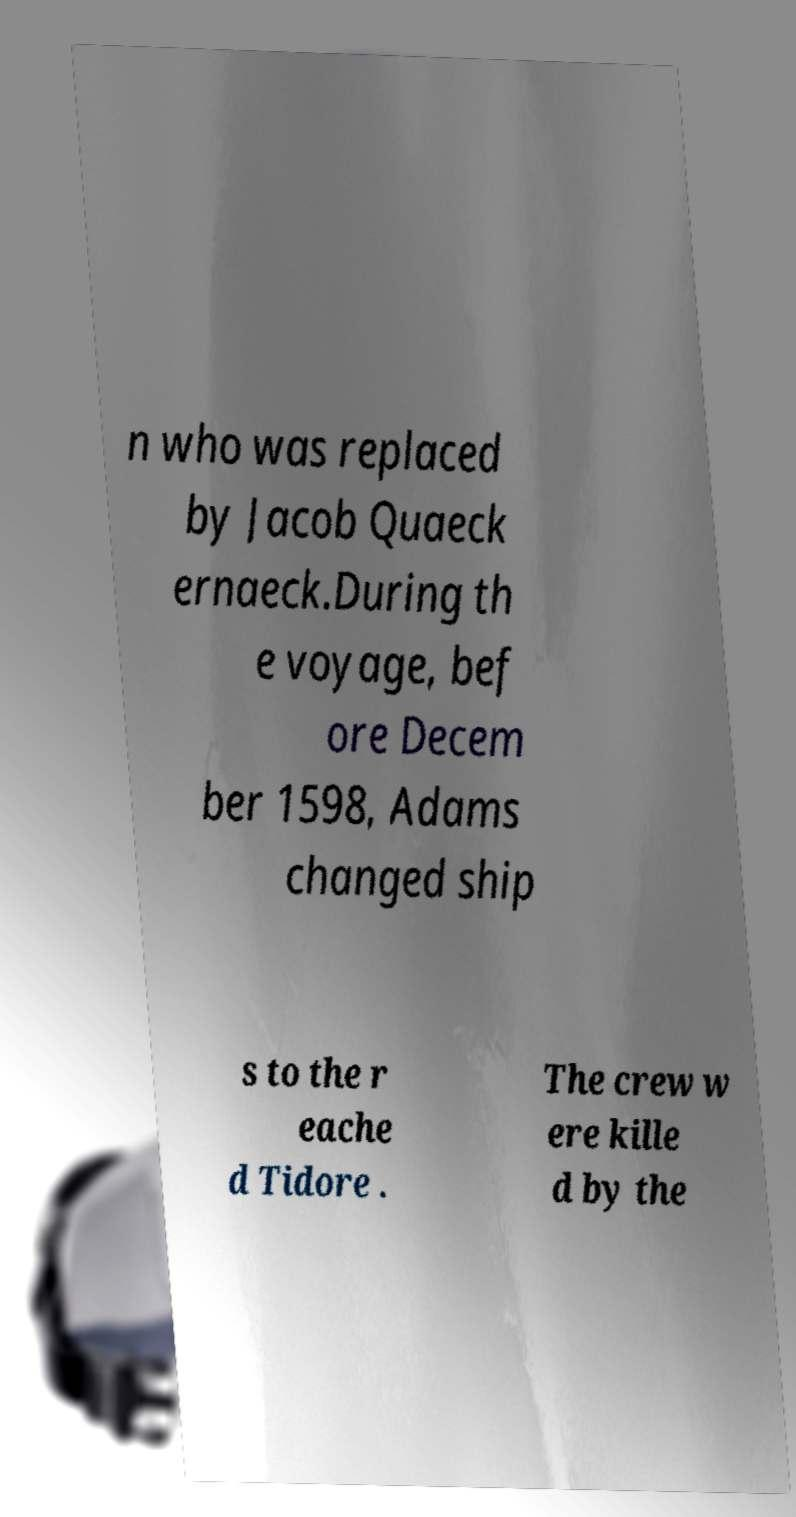For documentation purposes, I need the text within this image transcribed. Could you provide that? n who was replaced by Jacob Quaeck ernaeck.During th e voyage, bef ore Decem ber 1598, Adams changed ship s to the r eache d Tidore . The crew w ere kille d by the 